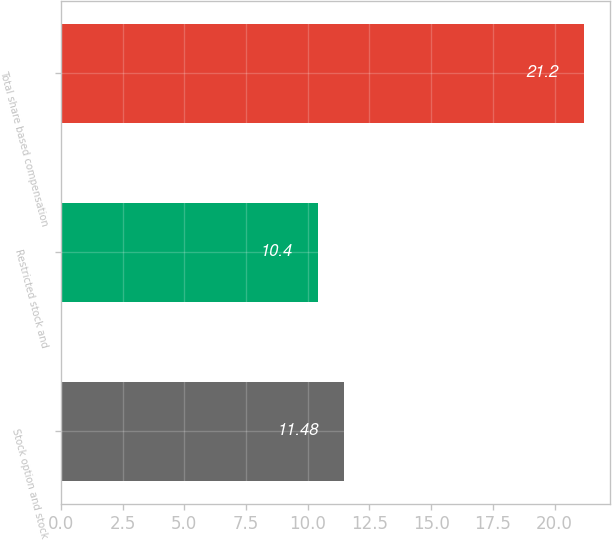Convert chart. <chart><loc_0><loc_0><loc_500><loc_500><bar_chart><fcel>Stock option and stock<fcel>Restricted stock and<fcel>Total share based compensation<nl><fcel>11.48<fcel>10.4<fcel>21.2<nl></chart> 